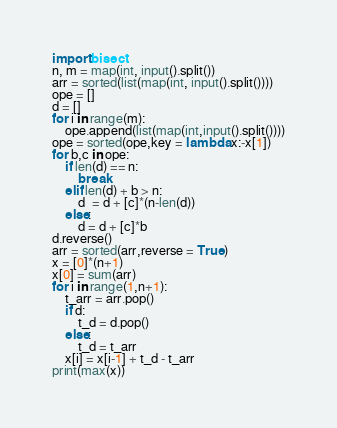Convert code to text. <code><loc_0><loc_0><loc_500><loc_500><_Python_>import bisect
n, m = map(int, input().split())
arr = sorted(list(map(int, input().split())))
ope = []
d = []
for i in range(m):
    ope.append(list(map(int,input().split())))
ope = sorted(ope,key = lambda x:-x[1])
for b,c in ope:
    if len(d) == n:
        break
    elif len(d) + b > n:
        d  = d + [c]*(n-len(d))
    else:
        d = d + [c]*b
d.reverse()
arr = sorted(arr,reverse = True)
x = [0]*(n+1)
x[0] = sum(arr)
for i in range(1,n+1):
    t_arr = arr.pop()
    if d:
        t_d = d.pop()
    else:
        t_d = t_arr
    x[i] = x[i-1] + t_d - t_arr
print(max(x))</code> 